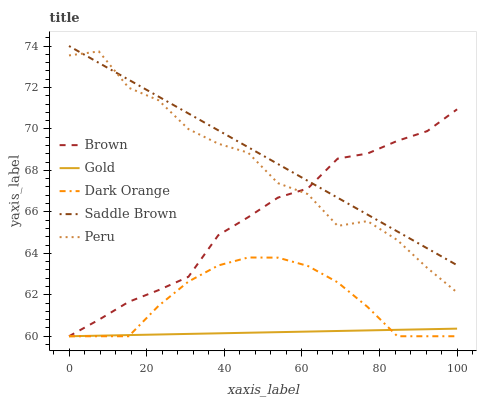Does Gold have the minimum area under the curve?
Answer yes or no. Yes. Does Saddle Brown have the maximum area under the curve?
Answer yes or no. Yes. Does Brown have the minimum area under the curve?
Answer yes or no. No. Does Brown have the maximum area under the curve?
Answer yes or no. No. Is Saddle Brown the smoothest?
Answer yes or no. Yes. Is Peru the roughest?
Answer yes or no. Yes. Is Brown the smoothest?
Answer yes or no. No. Is Brown the roughest?
Answer yes or no. No. Does Brown have the lowest value?
Answer yes or no. Yes. Does Saddle Brown have the lowest value?
Answer yes or no. No. Does Saddle Brown have the highest value?
Answer yes or no. Yes. Does Brown have the highest value?
Answer yes or no. No. Is Gold less than Peru?
Answer yes or no. Yes. Is Peru greater than Gold?
Answer yes or no. Yes. Does Brown intersect Gold?
Answer yes or no. Yes. Is Brown less than Gold?
Answer yes or no. No. Is Brown greater than Gold?
Answer yes or no. No. Does Gold intersect Peru?
Answer yes or no. No. 